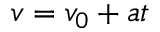<formula> <loc_0><loc_0><loc_500><loc_500>v = v _ { 0 } + a t</formula> 